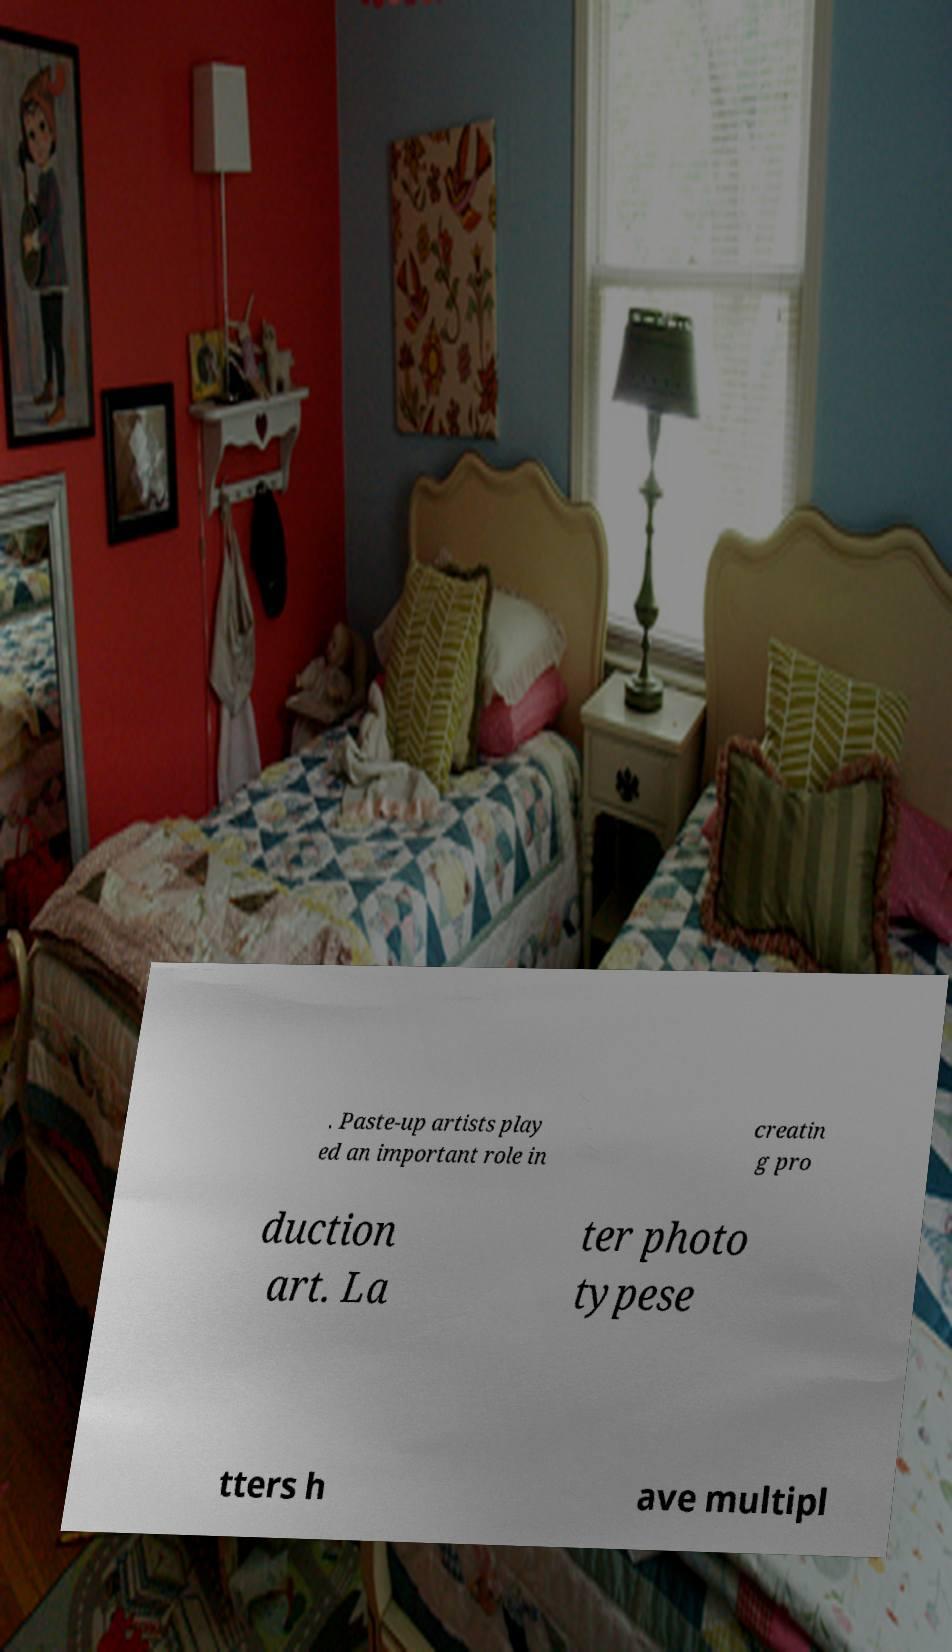Can you read and provide the text displayed in the image?This photo seems to have some interesting text. Can you extract and type it out for me? . Paste-up artists play ed an important role in creatin g pro duction art. La ter photo typese tters h ave multipl 